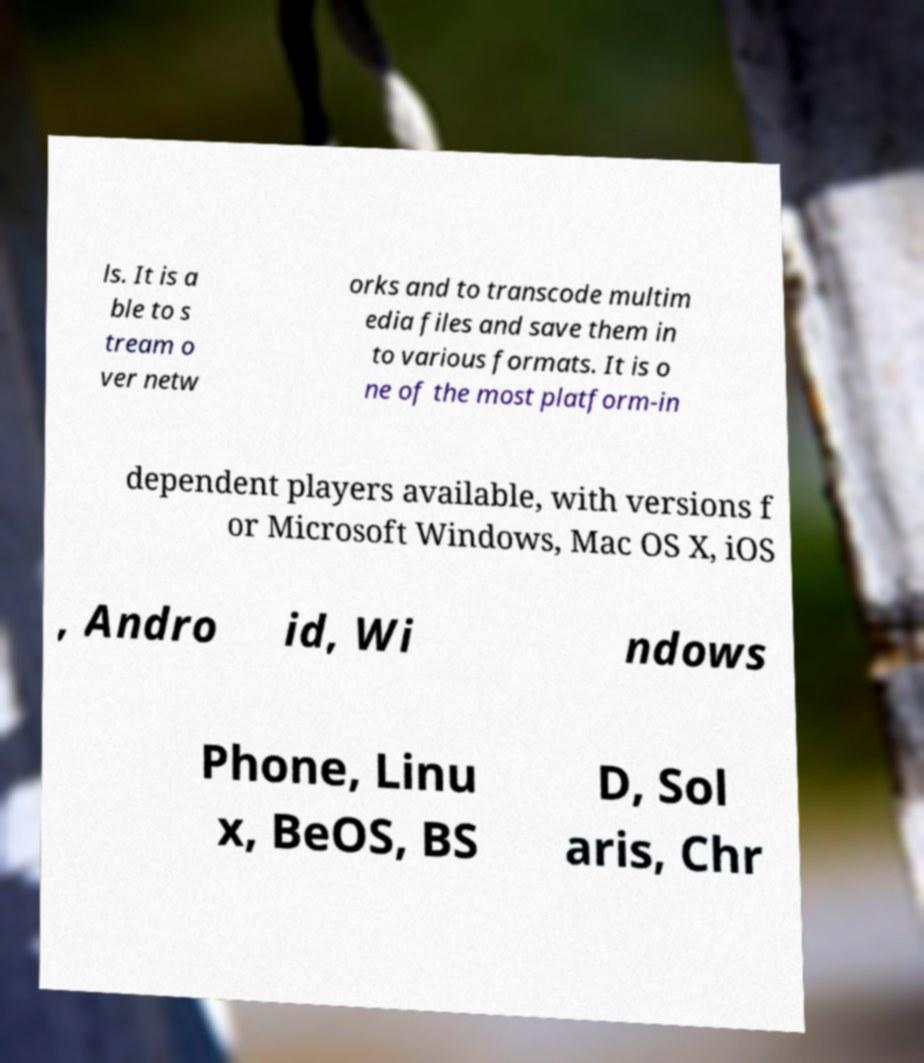Could you extract and type out the text from this image? ls. It is a ble to s tream o ver netw orks and to transcode multim edia files and save them in to various formats. It is o ne of the most platform-in dependent players available, with versions f or Microsoft Windows, Mac OS X, iOS , Andro id, Wi ndows Phone, Linu x, BeOS, BS D, Sol aris, Chr 